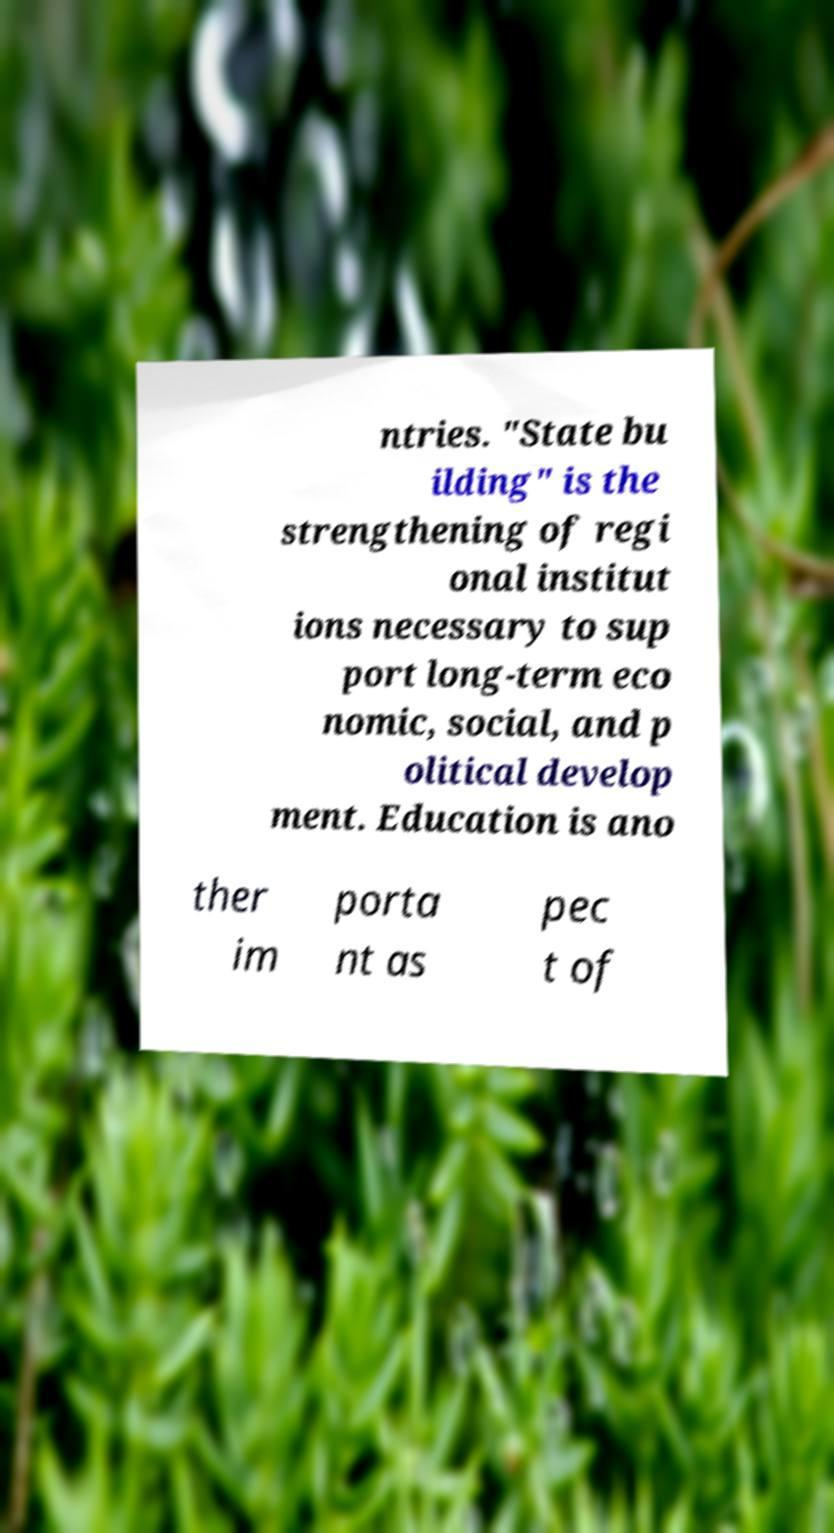Can you read and provide the text displayed in the image?This photo seems to have some interesting text. Can you extract and type it out for me? ntries. "State bu ilding" is the strengthening of regi onal institut ions necessary to sup port long-term eco nomic, social, and p olitical develop ment. Education is ano ther im porta nt as pec t of 